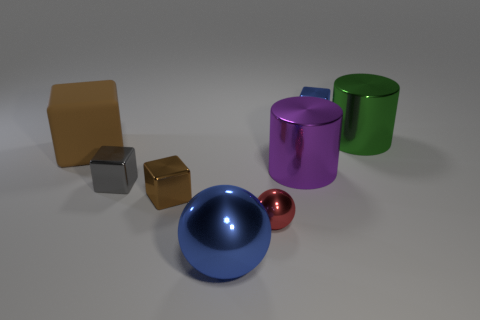Subtract all yellow blocks. Subtract all red cylinders. How many blocks are left? 4 Add 1 large brown blocks. How many objects exist? 9 Subtract all cylinders. How many objects are left? 6 Subtract all large blue metallic spheres. Subtract all big cyan matte objects. How many objects are left? 7 Add 3 big green shiny cylinders. How many big green shiny cylinders are left? 4 Add 3 spheres. How many spheres exist? 5 Subtract 1 blue balls. How many objects are left? 7 